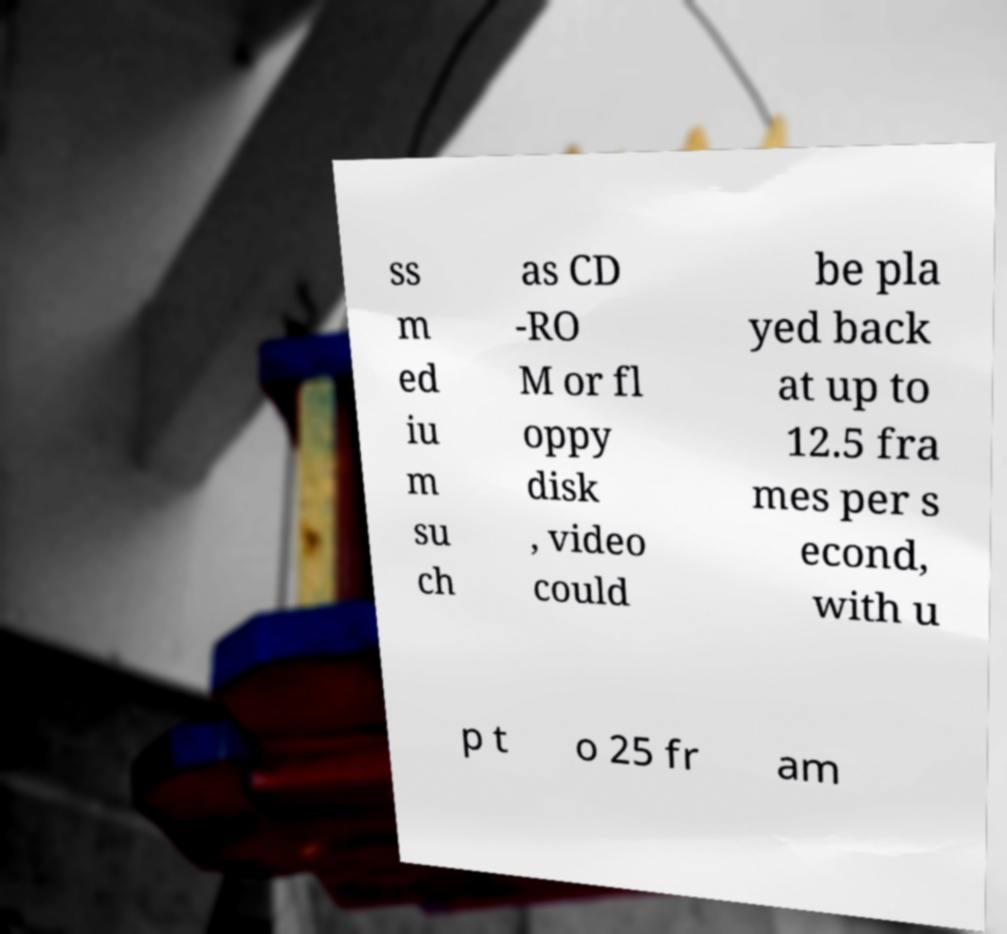For documentation purposes, I need the text within this image transcribed. Could you provide that? ss m ed iu m su ch as CD -RO M or fl oppy disk , video could be pla yed back at up to 12.5 fra mes per s econd, with u p t o 25 fr am 